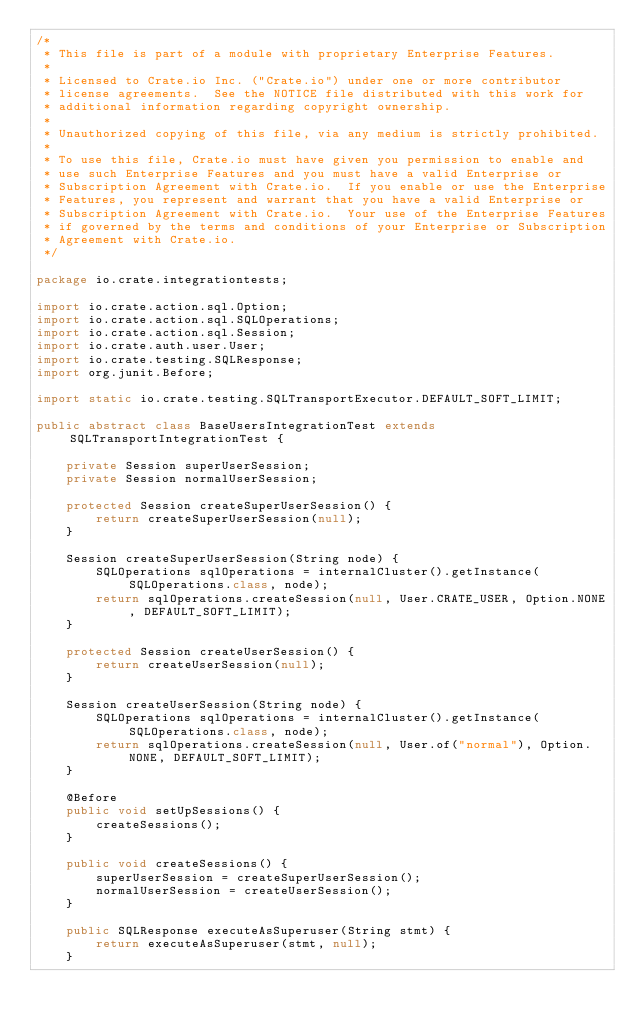Convert code to text. <code><loc_0><loc_0><loc_500><loc_500><_Java_>/*
 * This file is part of a module with proprietary Enterprise Features.
 *
 * Licensed to Crate.io Inc. ("Crate.io") under one or more contributor
 * license agreements.  See the NOTICE file distributed with this work for
 * additional information regarding copyright ownership.
 *
 * Unauthorized copying of this file, via any medium is strictly prohibited.
 *
 * To use this file, Crate.io must have given you permission to enable and
 * use such Enterprise Features and you must have a valid Enterprise or
 * Subscription Agreement with Crate.io.  If you enable or use the Enterprise
 * Features, you represent and warrant that you have a valid Enterprise or
 * Subscription Agreement with Crate.io.  Your use of the Enterprise Features
 * if governed by the terms and conditions of your Enterprise or Subscription
 * Agreement with Crate.io.
 */

package io.crate.integrationtests;

import io.crate.action.sql.Option;
import io.crate.action.sql.SQLOperations;
import io.crate.action.sql.Session;
import io.crate.auth.user.User;
import io.crate.testing.SQLResponse;
import org.junit.Before;

import static io.crate.testing.SQLTransportExecutor.DEFAULT_SOFT_LIMIT;

public abstract class BaseUsersIntegrationTest extends SQLTransportIntegrationTest {

    private Session superUserSession;
    private Session normalUserSession;

    protected Session createSuperUserSession() {
        return createSuperUserSession(null);
    }

    Session createSuperUserSession(String node) {
        SQLOperations sqlOperations = internalCluster().getInstance(SQLOperations.class, node);
        return sqlOperations.createSession(null, User.CRATE_USER, Option.NONE, DEFAULT_SOFT_LIMIT);
    }

    protected Session createUserSession() {
        return createUserSession(null);
    }

    Session createUserSession(String node) {
        SQLOperations sqlOperations = internalCluster().getInstance(SQLOperations.class, node);
        return sqlOperations.createSession(null, User.of("normal"), Option.NONE, DEFAULT_SOFT_LIMIT);
    }

    @Before
    public void setUpSessions() {
        createSessions();
    }

    public void createSessions() {
        superUserSession = createSuperUserSession();
        normalUserSession = createUserSession();
    }

    public SQLResponse executeAsSuperuser(String stmt) {
        return executeAsSuperuser(stmt, null);
    }
</code> 